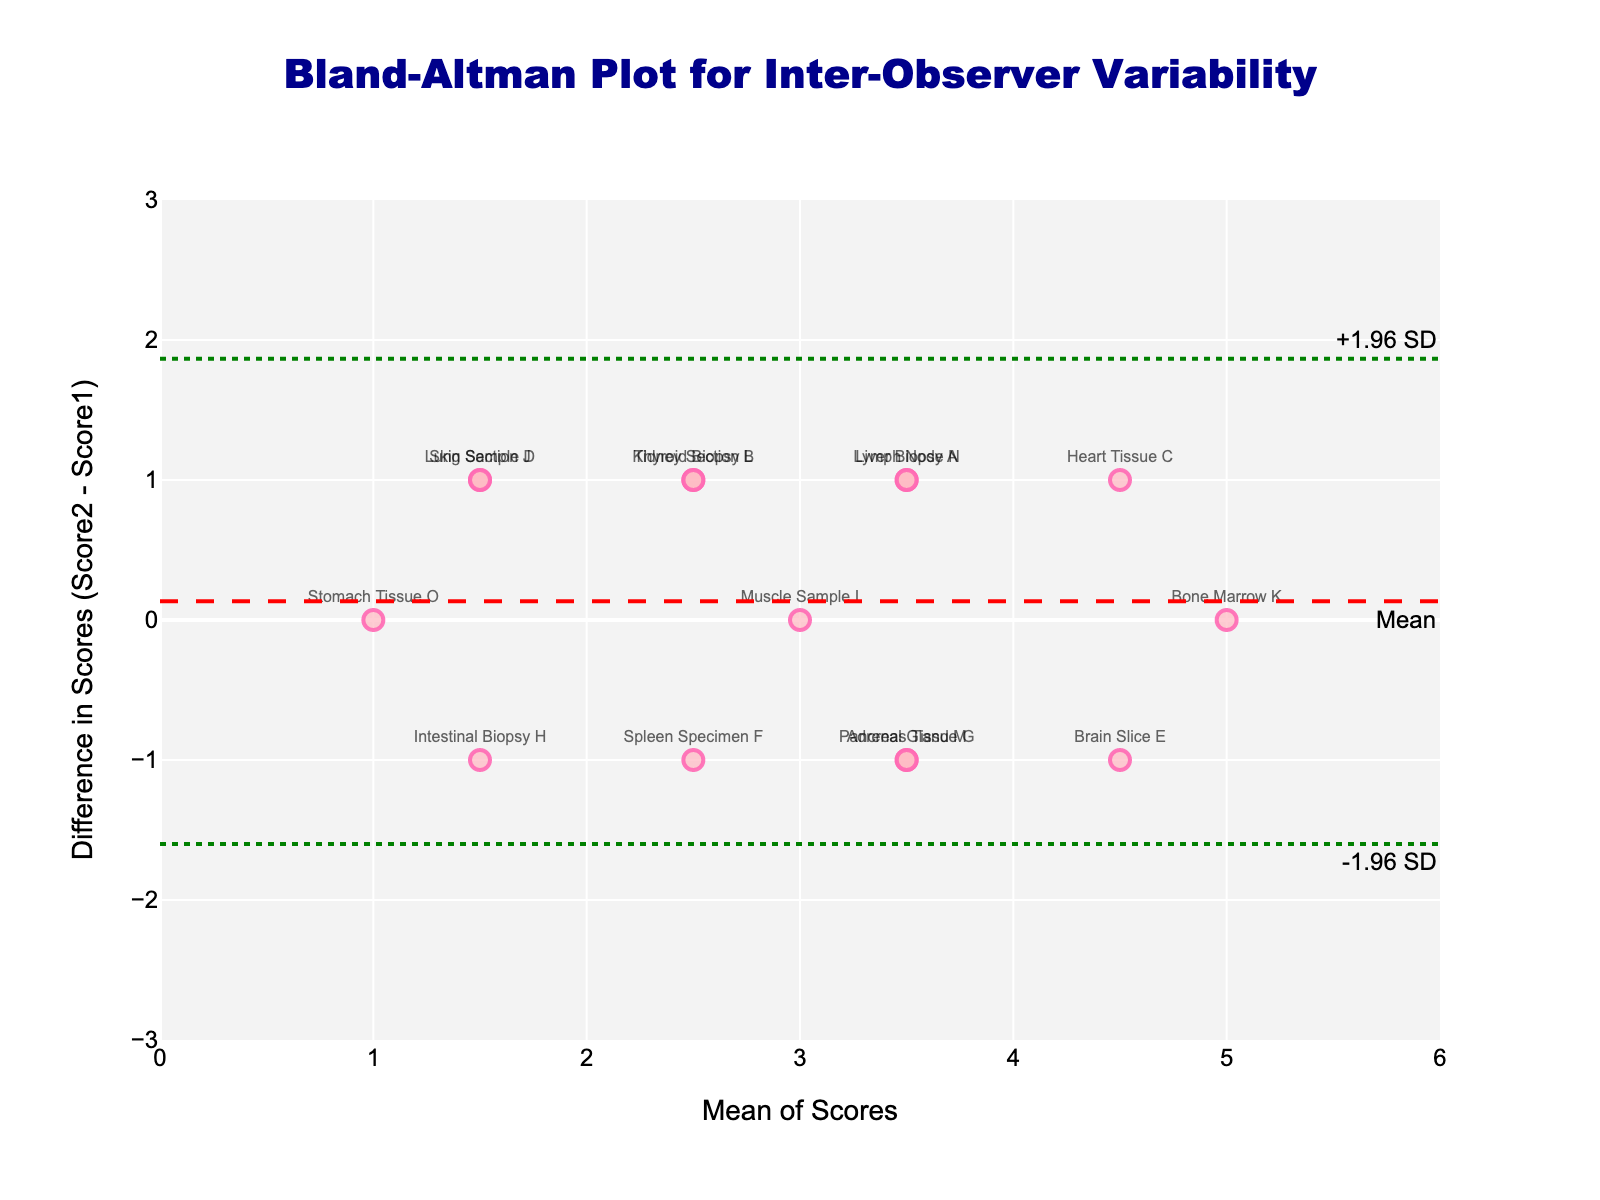What is the title of the plot? The title is the text that is centrally positioned at the top of the plot. Carefully reading it provides insights into what the plot is about.
Answer: Bland-Altman Plot for Inter-Observer Variability How many samples have been measured by the observers? To find the number of samples, count the number of data points or markers present in the scatter plot. Each marker represents one sample.
Answer: 15 What is the mean difference in the scores between the two observers? The mean difference is shown by the dashed red horizontal line labeled "Mean" on the plot.
Answer: 0 Which sample shows the largest positive difference in scores between the two observers? Identify the marker that has the highest positive value on the y-axis, then read the label next to this marker.
Answer: Heart Tissue C What are the upper and lower limits of agreement? The upper and lower limits of agreement are shown by the dotted green lines labeled "+1.96 SD" and "-1.96 SD" on the plot.
Answer: +1.96 and -1.96 What is the mean score for the sample "Kidney Section B"? Locate the "Kidney Section B" data point on the scatter plot, read its x-axis value which represents the mean score.
Answer: 2.5 Which sample scores have zero difference between the two observers? Look for markers that align horizontally on the zero (y=0) line and read their labels.
Answer: Muscle Sample I and Bone Marrow K Which sample has a mean score closest to 3? Identify the marker on the x-axis near the value 3, then read the label next to this marker.
Answer: Liver Biopsy A Are there any samples with a negative difference in scores? If yes, name one. Check for markers that are below the zero (y=0) line on the plot and read the labels of these markers.
Answer: Spleen Specimen F What is the difference in scores for the "Stomach Tissue O" sample? Locate the "Stomach Tissue O" data point on the scatter plot, read its y-axis value which represents the difference in scores.
Answer: 0 